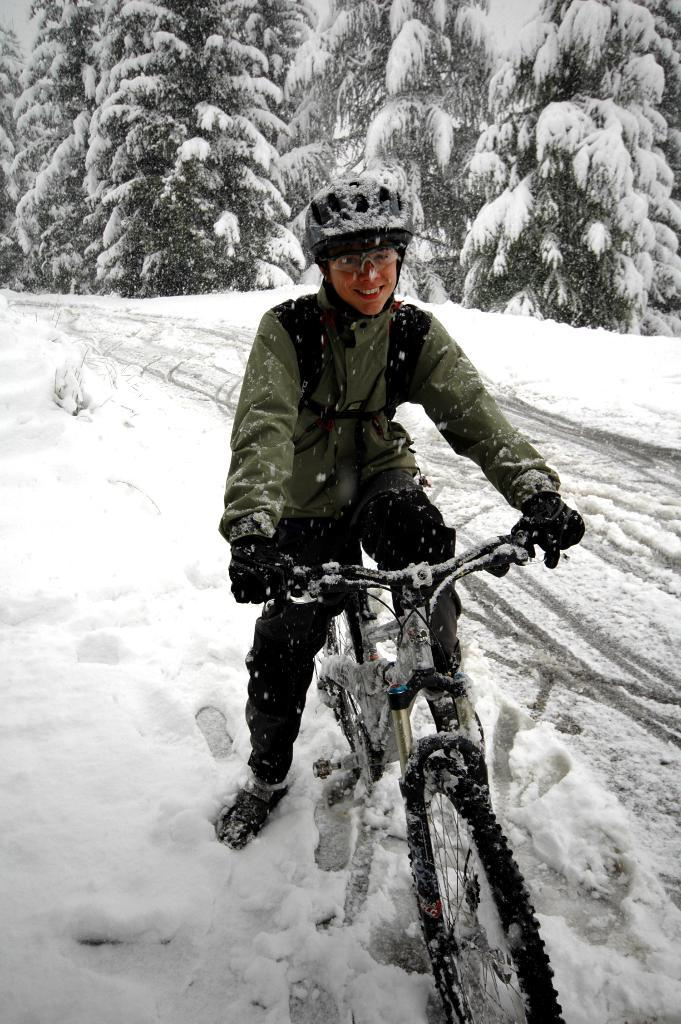Who is present in the image? There is a man in the image. What is the man wearing on his head? The man is wearing a helmet. What is the man wearing on his face? The man is wearing glasses. What is the man wearing on his upper body? The man is wearing a sweater. What activity is the man engaged in? The man is cycling. Where is the man cycling? The man is cycling on a snow land. What can be seen in the background of the image? There are trees in the background of the image. What is the condition of the trees in the image? The trees are covered with snow. What type of destruction can be seen in the image? There is no destruction present in the image; it features a man cycling on a snow land with trees in the background. What is the man using to carry heavy loads in the image? There is no yoke present in the image, and the man is not carrying any heavy loads. 